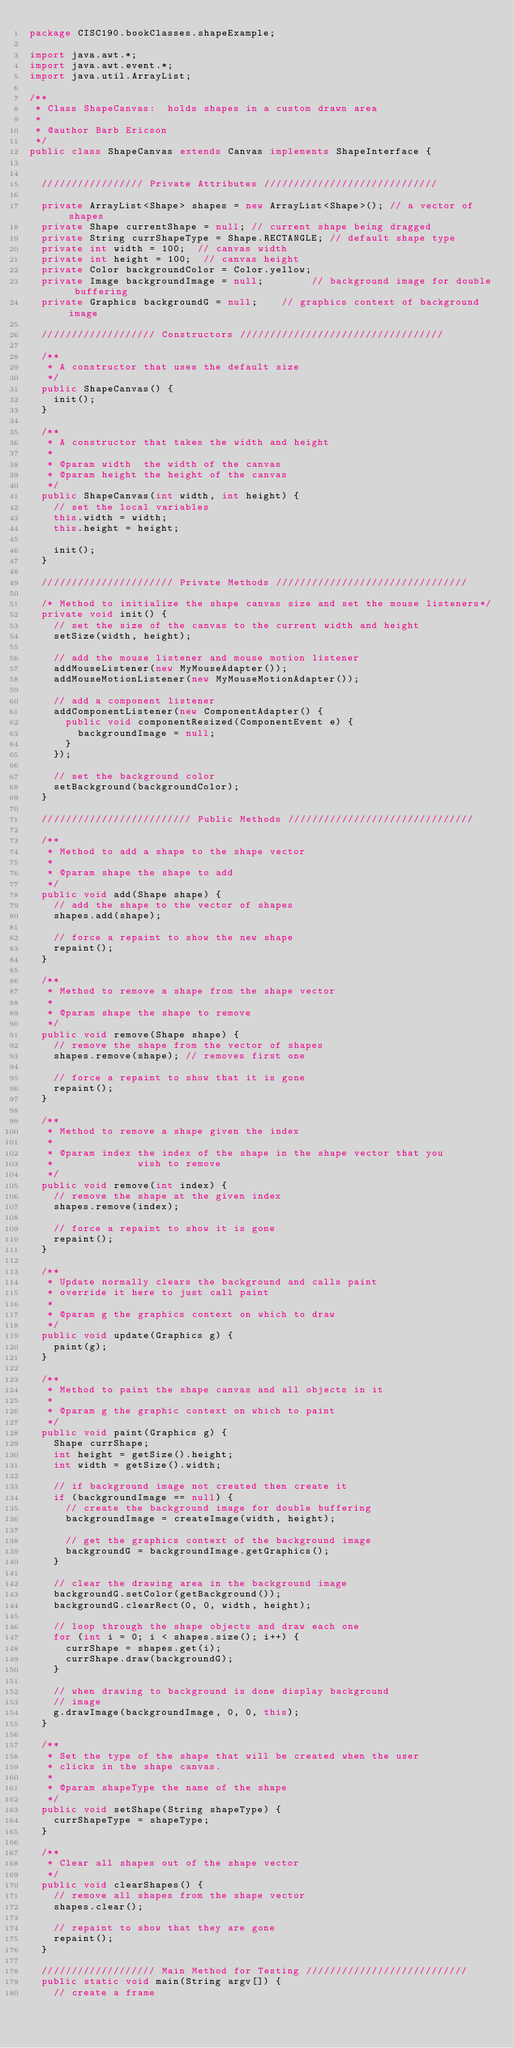Convert code to text. <code><loc_0><loc_0><loc_500><loc_500><_Java_>package CISC190.bookClasses.shapeExample;

import java.awt.*;
import java.awt.event.*;
import java.util.ArrayList;

/**
 * Class ShapeCanvas:  holds shapes in a custom drawn area
 *
 * @author Barb Ericson
 */
public class ShapeCanvas extends Canvas implements ShapeInterface {


	///////////////// Private Attributes /////////////////////////////

	private ArrayList<Shape> shapes = new ArrayList<Shape>(); // a vector of shapes
	private Shape currentShape = null; // current shape being dragged
	private String currShapeType = Shape.RECTANGLE; // default shape type
	private int width = 100;  // canvas width
	private int height = 100;  // canvas height
	private Color backgroundColor = Color.yellow;
	private Image backgroundImage = null;        // background image for double buffering
	private Graphics backgroundG = null;    // graphics context of background image

	/////////////////// Constructors //////////////////////////////////

	/**
	 * A constructor that uses the default size
	 */
	public ShapeCanvas() {
		init();
	}

	/**
	 * A constructor that takes the width and height
	 *
	 * @param width  the width of the canvas
	 * @param height the height of the canvas
	 */
	public ShapeCanvas(int width, int height) {
		// set the local variables
		this.width = width;
		this.height = height;

		init();
	}

	////////////////////// Private Methods ////////////////////////////////

	/* Method to initialize the shape canvas size and set the mouse listeners*/
	private void init() {
		// set the size of the canvas to the current width and height
		setSize(width, height);

		// add the mouse listener and mouse motion listener
		addMouseListener(new MyMouseAdapter());
		addMouseMotionListener(new MyMouseMotionAdapter());

		// add a component listener
		addComponentListener(new ComponentAdapter() {
			public void componentResized(ComponentEvent e) {
				backgroundImage = null;
			}
		});

		// set the background color
		setBackground(backgroundColor);
	}

	///////////////////////// Public Methods ///////////////////////////////

	/**
	 * Method to add a shape to the shape vector
	 *
	 * @param shape the shape to add
	 */
	public void add(Shape shape) {
		// add the shape to the vector of shapes
		shapes.add(shape);

		// force a repaint to show the new shape
		repaint();
	}

	/**
	 * Method to remove a shape from the shape vector
	 *
	 * @param shape the shape to remove
	 */
	public void remove(Shape shape) {
		// remove the shape from the vector of shapes
		shapes.remove(shape); // removes first one

		// force a repaint to show that it is gone
		repaint();
	}

	/**
	 * Method to remove a shape given the index
	 *
	 * @param index the index of the shape in the shape vector that you
	 *              wish to remove
	 */
	public void remove(int index) {
		// remove the shape at the given index
		shapes.remove(index);

		// force a repaint to show it is gone
		repaint();
	}

	/**
	 * Update normally clears the background and calls paint
	 * override it here to just call paint
	 *
	 * @param g the graphics context on which to draw
	 */
	public void update(Graphics g) {
		paint(g);
	}

	/**
	 * Method to paint the shape canvas and all objects in it
	 *
	 * @param g the graphic context on which to paint
	 */
	public void paint(Graphics g) {
		Shape currShape;
		int height = getSize().height;
		int width = getSize().width;

		// if background image not created then create it
		if (backgroundImage == null) {
			// create the background image for double buffering
			backgroundImage = createImage(width, height);

			// get the graphics context of the background image
			backgroundG = backgroundImage.getGraphics();
		}

		// clear the drawing area in the background image
		backgroundG.setColor(getBackground());
		backgroundG.clearRect(0, 0, width, height);

		// loop through the shape objects and draw each one
		for (int i = 0; i < shapes.size(); i++) {
			currShape = shapes.get(i);
			currShape.draw(backgroundG);
		}

		// when drawing to background is done display background
		// image
		g.drawImage(backgroundImage, 0, 0, this);
	}

	/**
	 * Set the type of the shape that will be created when the user
	 * clicks in the shape canvas.
	 *
	 * @param shapeType the name of the shape
	 */
	public void setShape(String shapeType) {
		currShapeType = shapeType;
	}

	/**
	 * Clear all shapes out of the shape vector
	 */
	public void clearShapes() {
		// remove all shapes from the shape vector
		shapes.clear();

		// repaint to show that they are gone
		repaint();
	}

	/////////////////// Main Method for Testing ///////////////////////////
	public static void main(String argv[]) {
		// create a frame</code> 